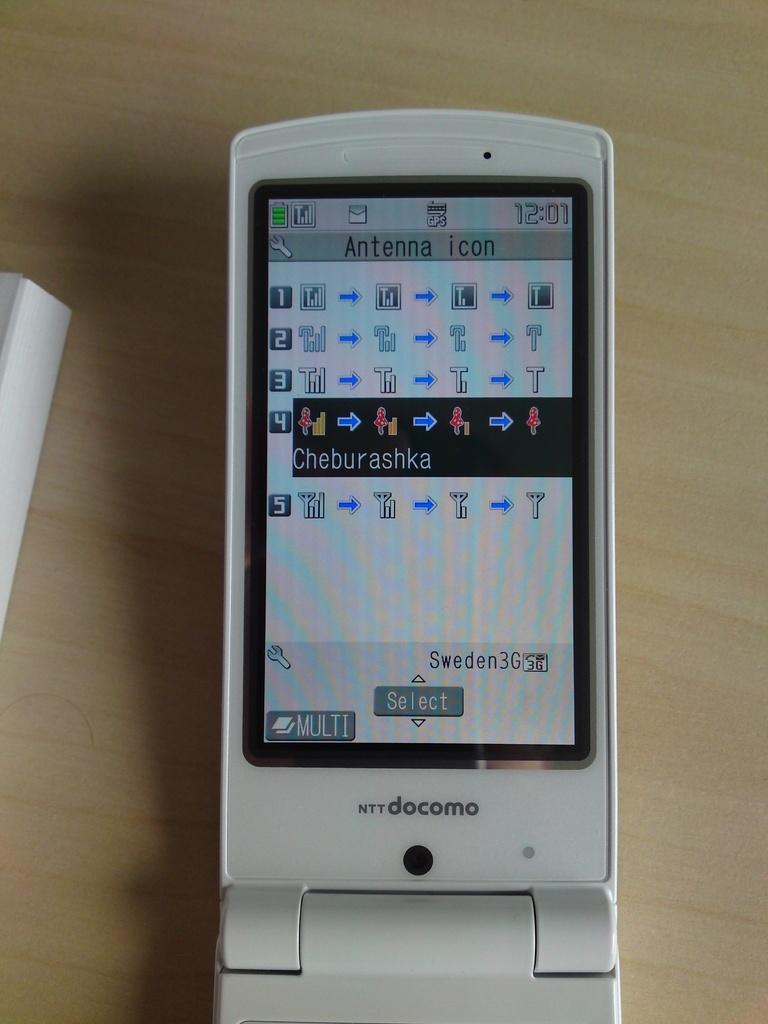<image>
Describe the image concisely. An old docomo mobile has various icons and the word Cheburashka on its screen. 